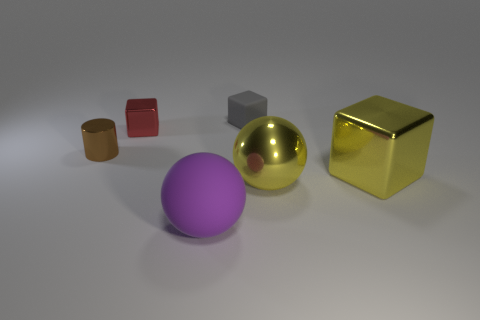There is a gray block that is the same size as the brown thing; what material is it?
Make the answer very short. Rubber. What color is the thing on the right side of the large yellow thing left of the yellow cube?
Make the answer very short. Yellow. How many purple objects are behind the small red metallic object?
Offer a very short reply. 0. The metallic cylinder has what color?
Keep it short and to the point. Brown. How many large objects are either matte objects or gray rubber blocks?
Give a very brief answer. 1. There is a large thing that is to the left of the tiny matte object; is its color the same as the thing on the left side of the small red thing?
Offer a terse response. No. What number of other things are there of the same color as the cylinder?
Your response must be concise. 0. What is the shape of the large thing that is left of the gray matte cube?
Offer a very short reply. Sphere. Are there fewer tiny rubber things than small metallic things?
Ensure brevity in your answer.  Yes. Is the cube left of the purple matte sphere made of the same material as the large yellow ball?
Your answer should be very brief. Yes. 